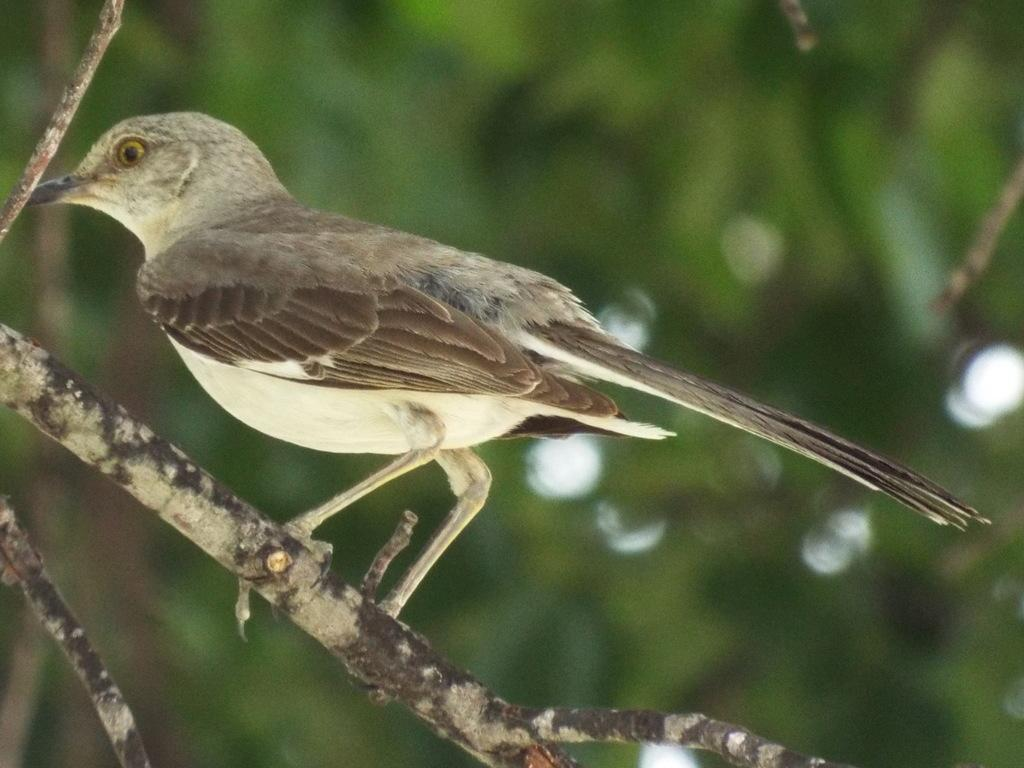What type of animal is in the image? There is a bird in the image. Where is the bird located? The bird is standing on a tree branch. What can be seen in the background of the image? There is a tree in the background of the image. How would you describe the background of the image? The background image appears blurry. What is the bird's interest in the things happening in the background? There is no indication in the image of the bird having any interest in the background, as it is focused on standing on the tree branch. 